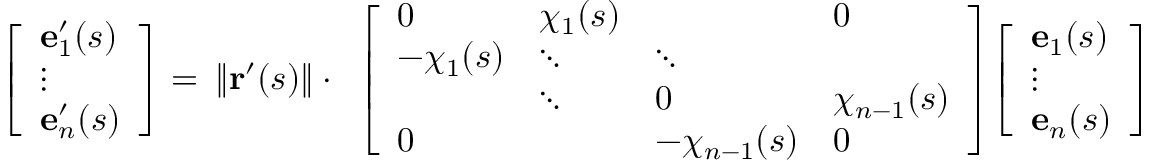<formula> <loc_0><loc_0><loc_500><loc_500>{ \begin{array} { r } { { \left [ \begin{array} { l } { e _ { 1 } ^ { \prime } ( s ) } \\ { \vdots } \\ { e _ { n } ^ { \prime } ( s ) } \end{array} \right ] } = } \end{array} } \| r ^ { \prime } ( s ) \| \cdot { \begin{array} { r } { { \left [ \begin{array} { l l l l } { 0 } & { \chi _ { 1 } ( s ) } & & { 0 } \\ { - \chi _ { 1 } ( s ) } & { \ddots } & { \ddots } & \\ & { \ddots } & { 0 } & { \chi _ { n - 1 } ( s ) } \\ { 0 } & & { - \chi _ { n - 1 } ( s ) } & { 0 } \end{array} \right ] } { \left [ \begin{array} { l } { e _ { 1 } ( s ) } \\ { \vdots } \\ { e _ { n } ( s ) } \end{array} \right ] } } \end{array} }</formula> 